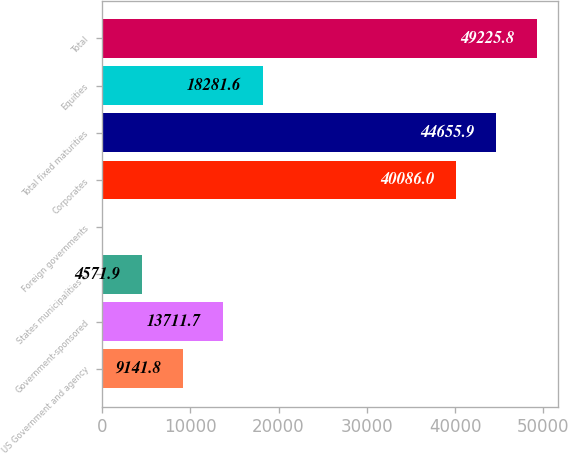Convert chart to OTSL. <chart><loc_0><loc_0><loc_500><loc_500><bar_chart><fcel>US Government and agency<fcel>Government-sponsored<fcel>States municipalities &<fcel>Foreign governments<fcel>Corporates<fcel>Total fixed maturities<fcel>Equities<fcel>Total<nl><fcel>9141.8<fcel>13711.7<fcel>4571.9<fcel>2<fcel>40086<fcel>44655.9<fcel>18281.6<fcel>49225.8<nl></chart> 